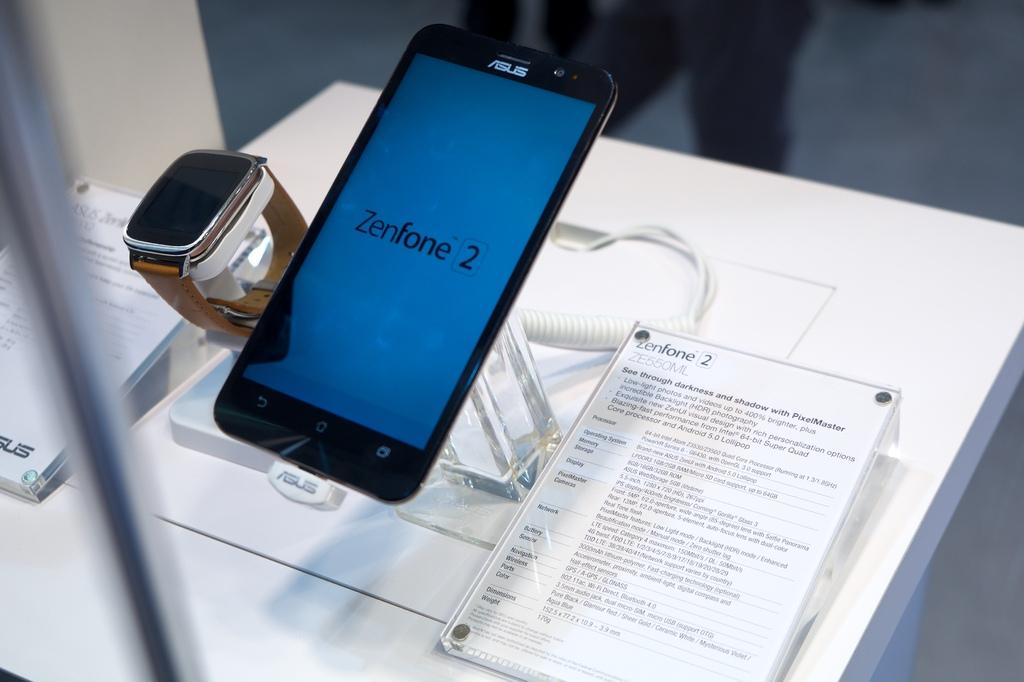What electronic device is visible in the image? There is a mobile phone in the image. What time-keeping device is present in the image? There is a watch in the image. How many text boards are in the image? There are two text boards in the image. What type of object is present that might be used for transmitting signals or power? There is a wire in the image. What is the color of the table in the image? There is a white color table in the image. What type of road can be seen in the image? There is no road present in the image. How does the disease spread in the image? There is no mention of a disease in the image. 